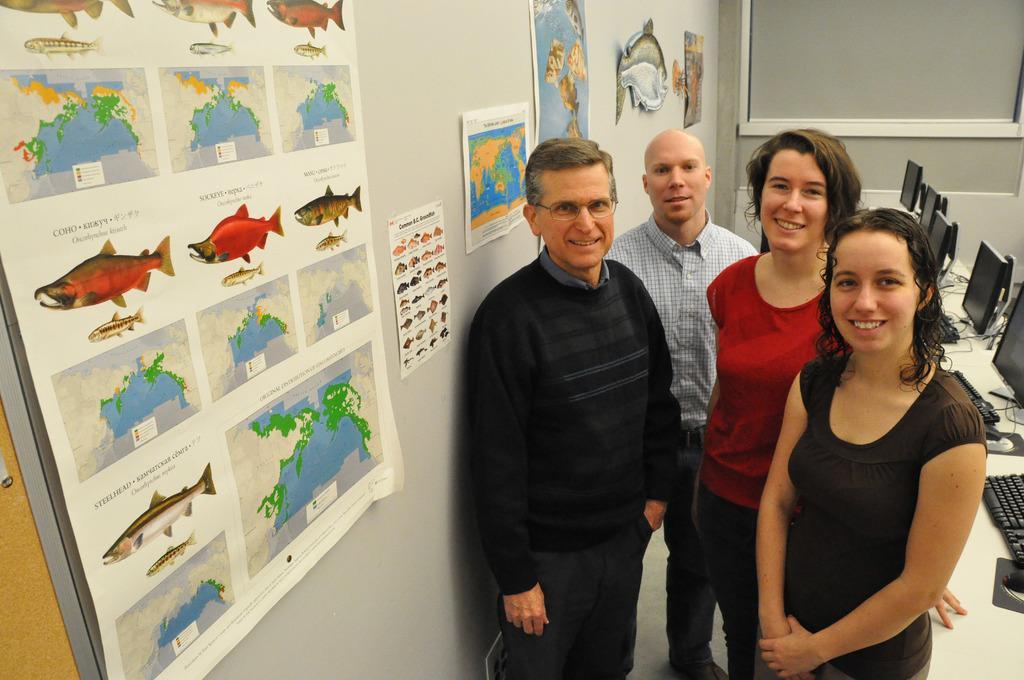How would you summarize this image in a sentence or two? In the picture we can see four people are standing on the floor, two are men and two are women and they are smiling and beside women we can see some computer systems and keyboards on the desk and beside men we can see a wall with some posters of fish and world map and in the background we can see a wall. 